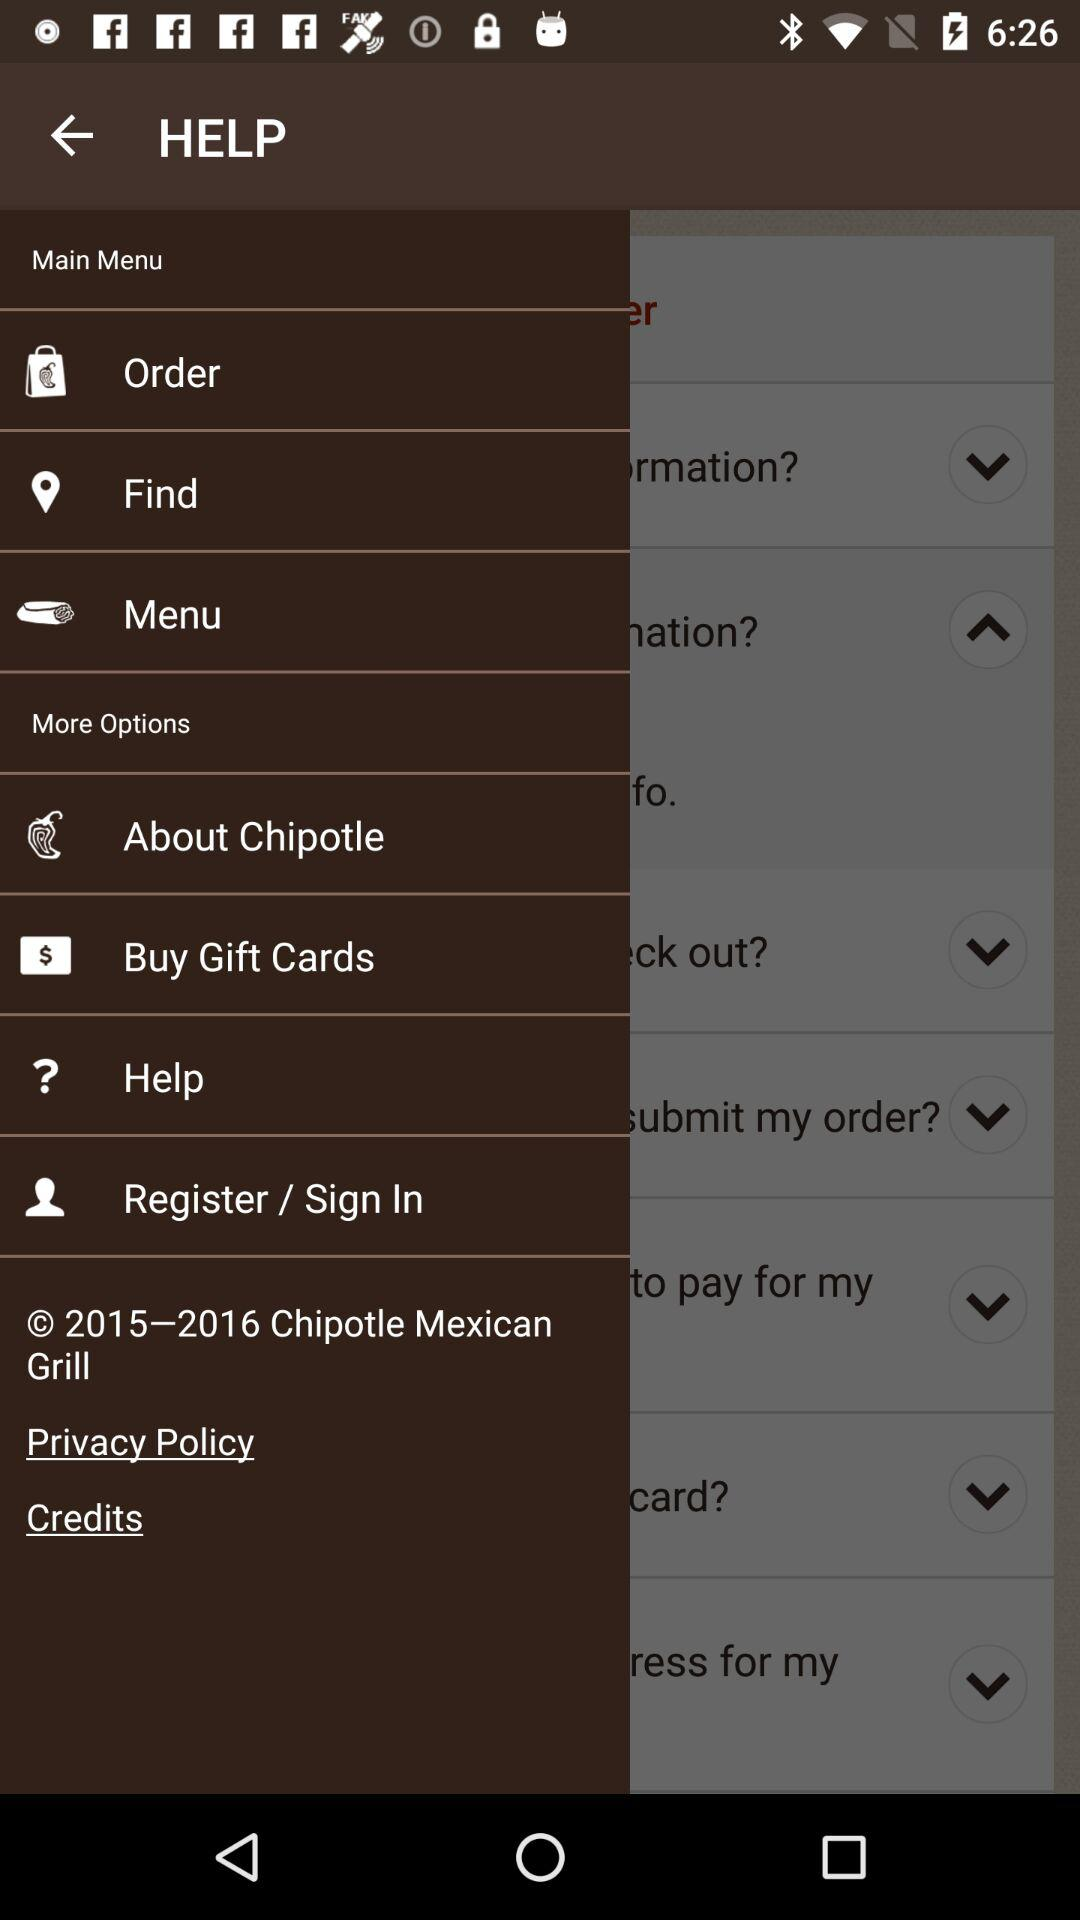What is the year of copyright for the application? The copyright year for the application is from 2015 to 2016. 